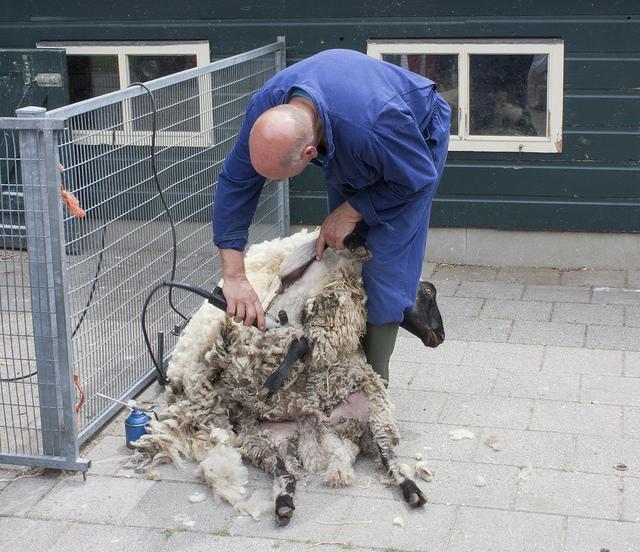Is the statement "The person is touching the sheep." accurate regarding the image?
Answer yes or no. Yes. Is the caption "The person is connected to the sheep." a true representation of the image?
Answer yes or no. No. Verify the accuracy of this image caption: "The sheep is beneath the person.".
Answer yes or no. Yes. Is this affirmation: "The sheep is touching the person." correct?
Answer yes or no. Yes. 